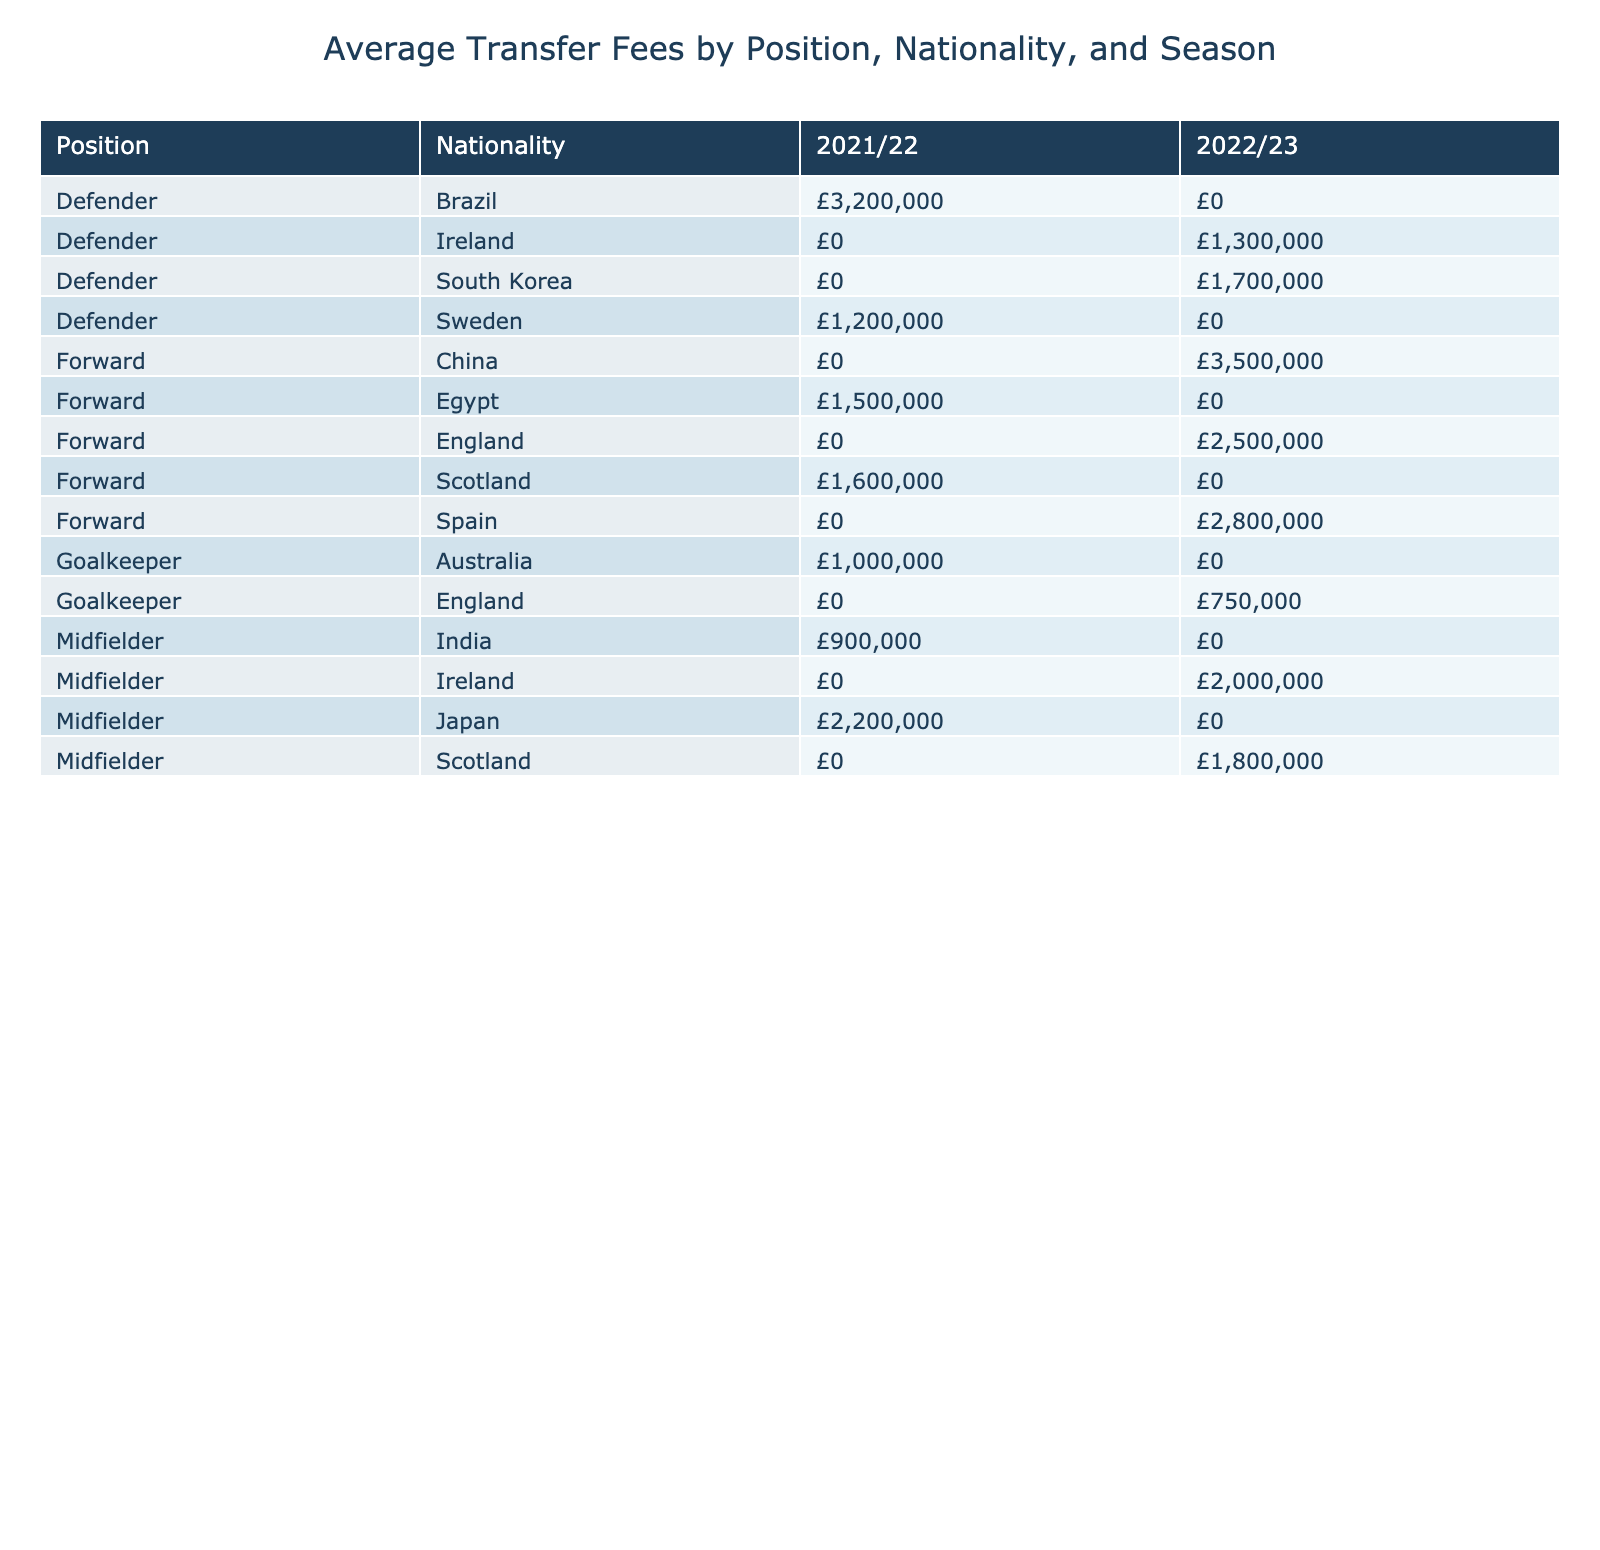What is the average transfer fee for forwards in the 2022/23 season? The table shows the average transfer fees for forwards categorized by season. Looking specifically at the row for forwards in the 2022/23 season, we have two players: Jack Thompson with a fee of £2,500,000 and Kai Chen with a fee of £3,500,000. The average can be calculated as (2,500,000 + 3,500,000) / 2 = £3,000,000.
Answer: £3,000,000 Which nationality has the highest average transfer fee in the 2021/22 season? To find this, we need to look at both the Defender and Midfielder positions in the 2021/22 season. For defenders, Lucas Silva from Brazil has a fee of £3,200,000, while Sofia Andersson from Sweden has a fee of £1,200,000. So the average for Brazil is £3,200,000 and for Sweden is £1,200,000. The nationality with the highest fee is Brazil.
Answer: Brazil Is the average market value of goalkeepers higher in the 2022/23 season than in the 2021/22 season? The table states there are two goalkeepers in the 2022/23 season (Sarah Johnson with £1,000,000 and Olivia Brown with £1,300,000) and in the 2021/22 season, there is only one goalkeeper (Olivia Brown with £1,300,000). Calculating the average for 2022/23 gives (£1,000,000 + £1,300,000) / 2 = £1,150,000. Since there is one value of £1,300,000 in the previous season, £1,150,000 < £1,300,000. Thus, the average market value for goalkeepers is lower in 2022/23.
Answer: No What is the total transfer fee for defenders in the 2022/23 season? In the table, for the 2022/23 season, there is one defender, Daniel Kim, with a transfer fee of £1,700,000. Since he is the only defender in this season, the total transfer fee equals his fee which is £1,700,000.
Answer: £1,700,000 Does any midfielder in the 2022/23 season have a transfer fee below £2,000,000? From the table, looking at the midfielders in the 2022/23 season, we see Liam O'Connor with £2,000,000 and Emma Wilson with £1,800,000. Since £1,800,000 is below £2,000,000, at least one midfielder does have a fee below this amount.
Answer: Yes 